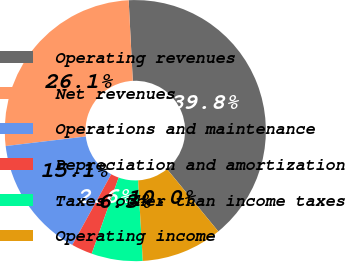<chart> <loc_0><loc_0><loc_500><loc_500><pie_chart><fcel>Operating revenues<fcel>Net revenues<fcel>Operations and maintenance<fcel>Depreciation and amortization<fcel>Taxes other than income taxes<fcel>Operating income<nl><fcel>39.85%<fcel>26.08%<fcel>15.1%<fcel>2.6%<fcel>6.33%<fcel>10.05%<nl></chart> 